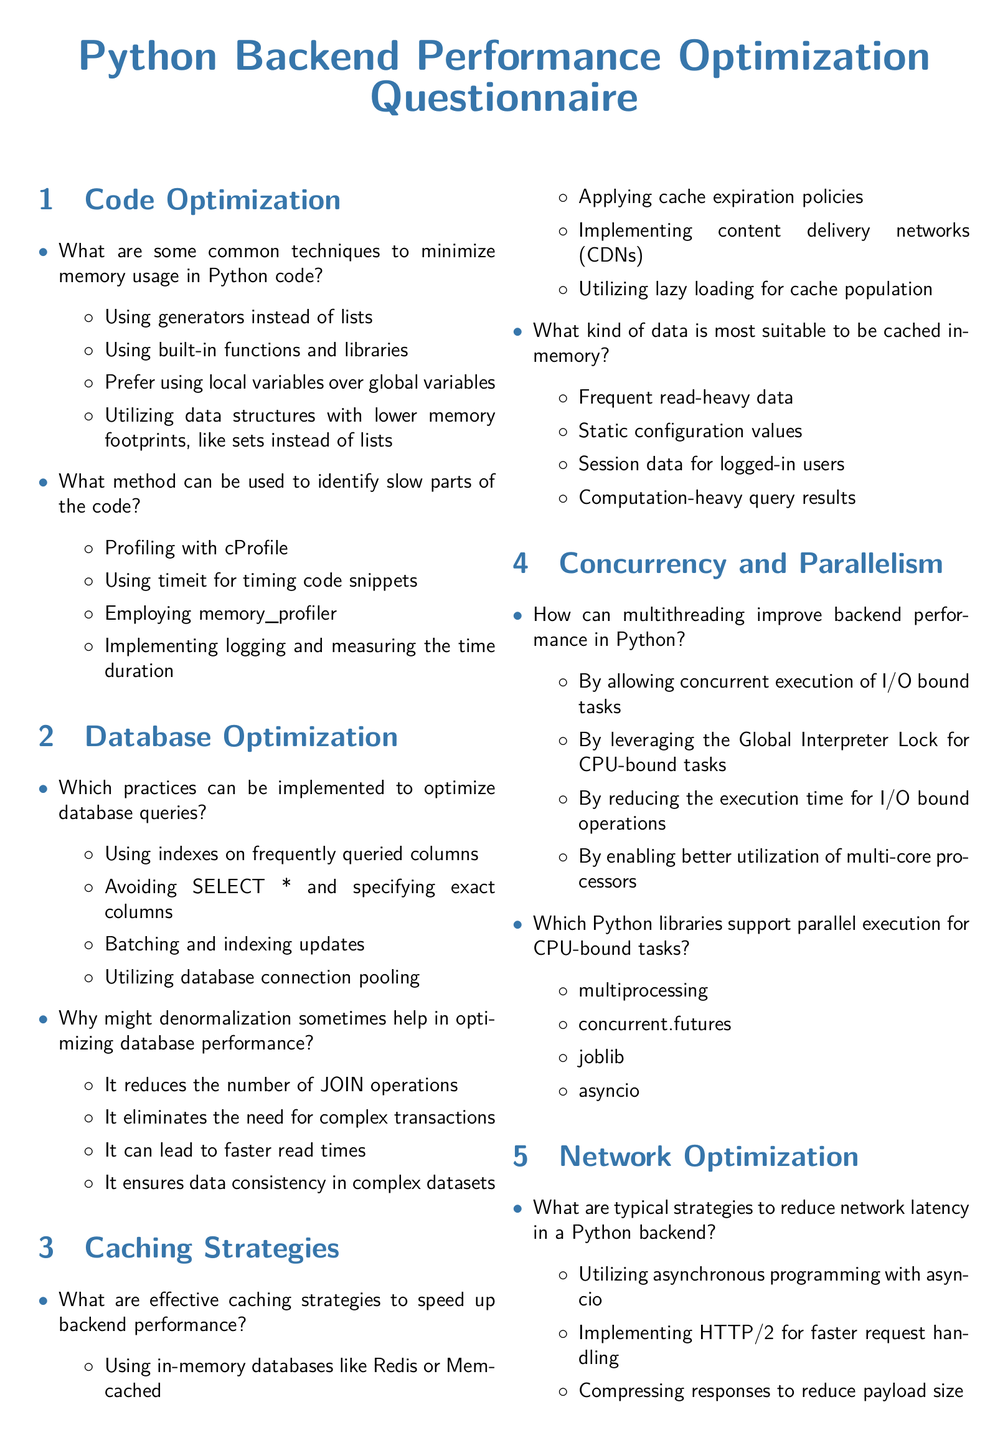What are some techniques to minimize memory usage in Python code? The document lists techniques such as using generators instead of lists and utilizing data structures with lower memory footprints.
Answer: Generators instead of lists What method can help identify slow parts of the code? This can be achieved through profiling, which helps in finding performance bottlenecks in the code.
Answer: Profiling with cProfile Which practice helps optimize database queries? The document mentions practices like using indexes on frequently queried columns and avoiding SELECT * queries.
Answer: Using indexes on frequently queried columns What are effective caching strategies to speed up backend performance? Caching strategies mentioned include using in-memory databases and applying cache expiration policies.
Answer: Using in-memory databases How can multithreading improve backend performance in Python? The document states that multithreading facilitates concurrent execution of I/O bound tasks, leading to performance gains.
Answer: Concurrent execution of I/O bound tasks What is a key advantage of denormalization in database optimization? Denormalization is said to help by reducing the number of JOIN operations required during queries.
Answer: Reducing the number of JOIN operations What is the significance of connection pooling? Connection pooling is significant for reducing the overhead of establishing new connections.
Answer: Reducing overhead of establishing new connections Which libraries support parallel execution for CPU-bound tasks? The document lists libraries such as multiprocessing and concurrent.futures as supportive of parallel execution.
Answer: multiprocessing What is a typical strategy to reduce network latency in a Python backend? Typical strategies include utilizing asynchronous programming and implementing HTTP/2 for faster request handling.
Answer: Utilizing asynchronous programming 